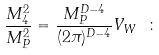<formula> <loc_0><loc_0><loc_500><loc_500>\frac { M _ { 4 } ^ { 2 } } { M _ { P } ^ { 2 } } = \frac { M _ { P } ^ { D - 4 } } { ( 2 \pi ) ^ { D - 4 } } V _ { W } \ \colon</formula> 